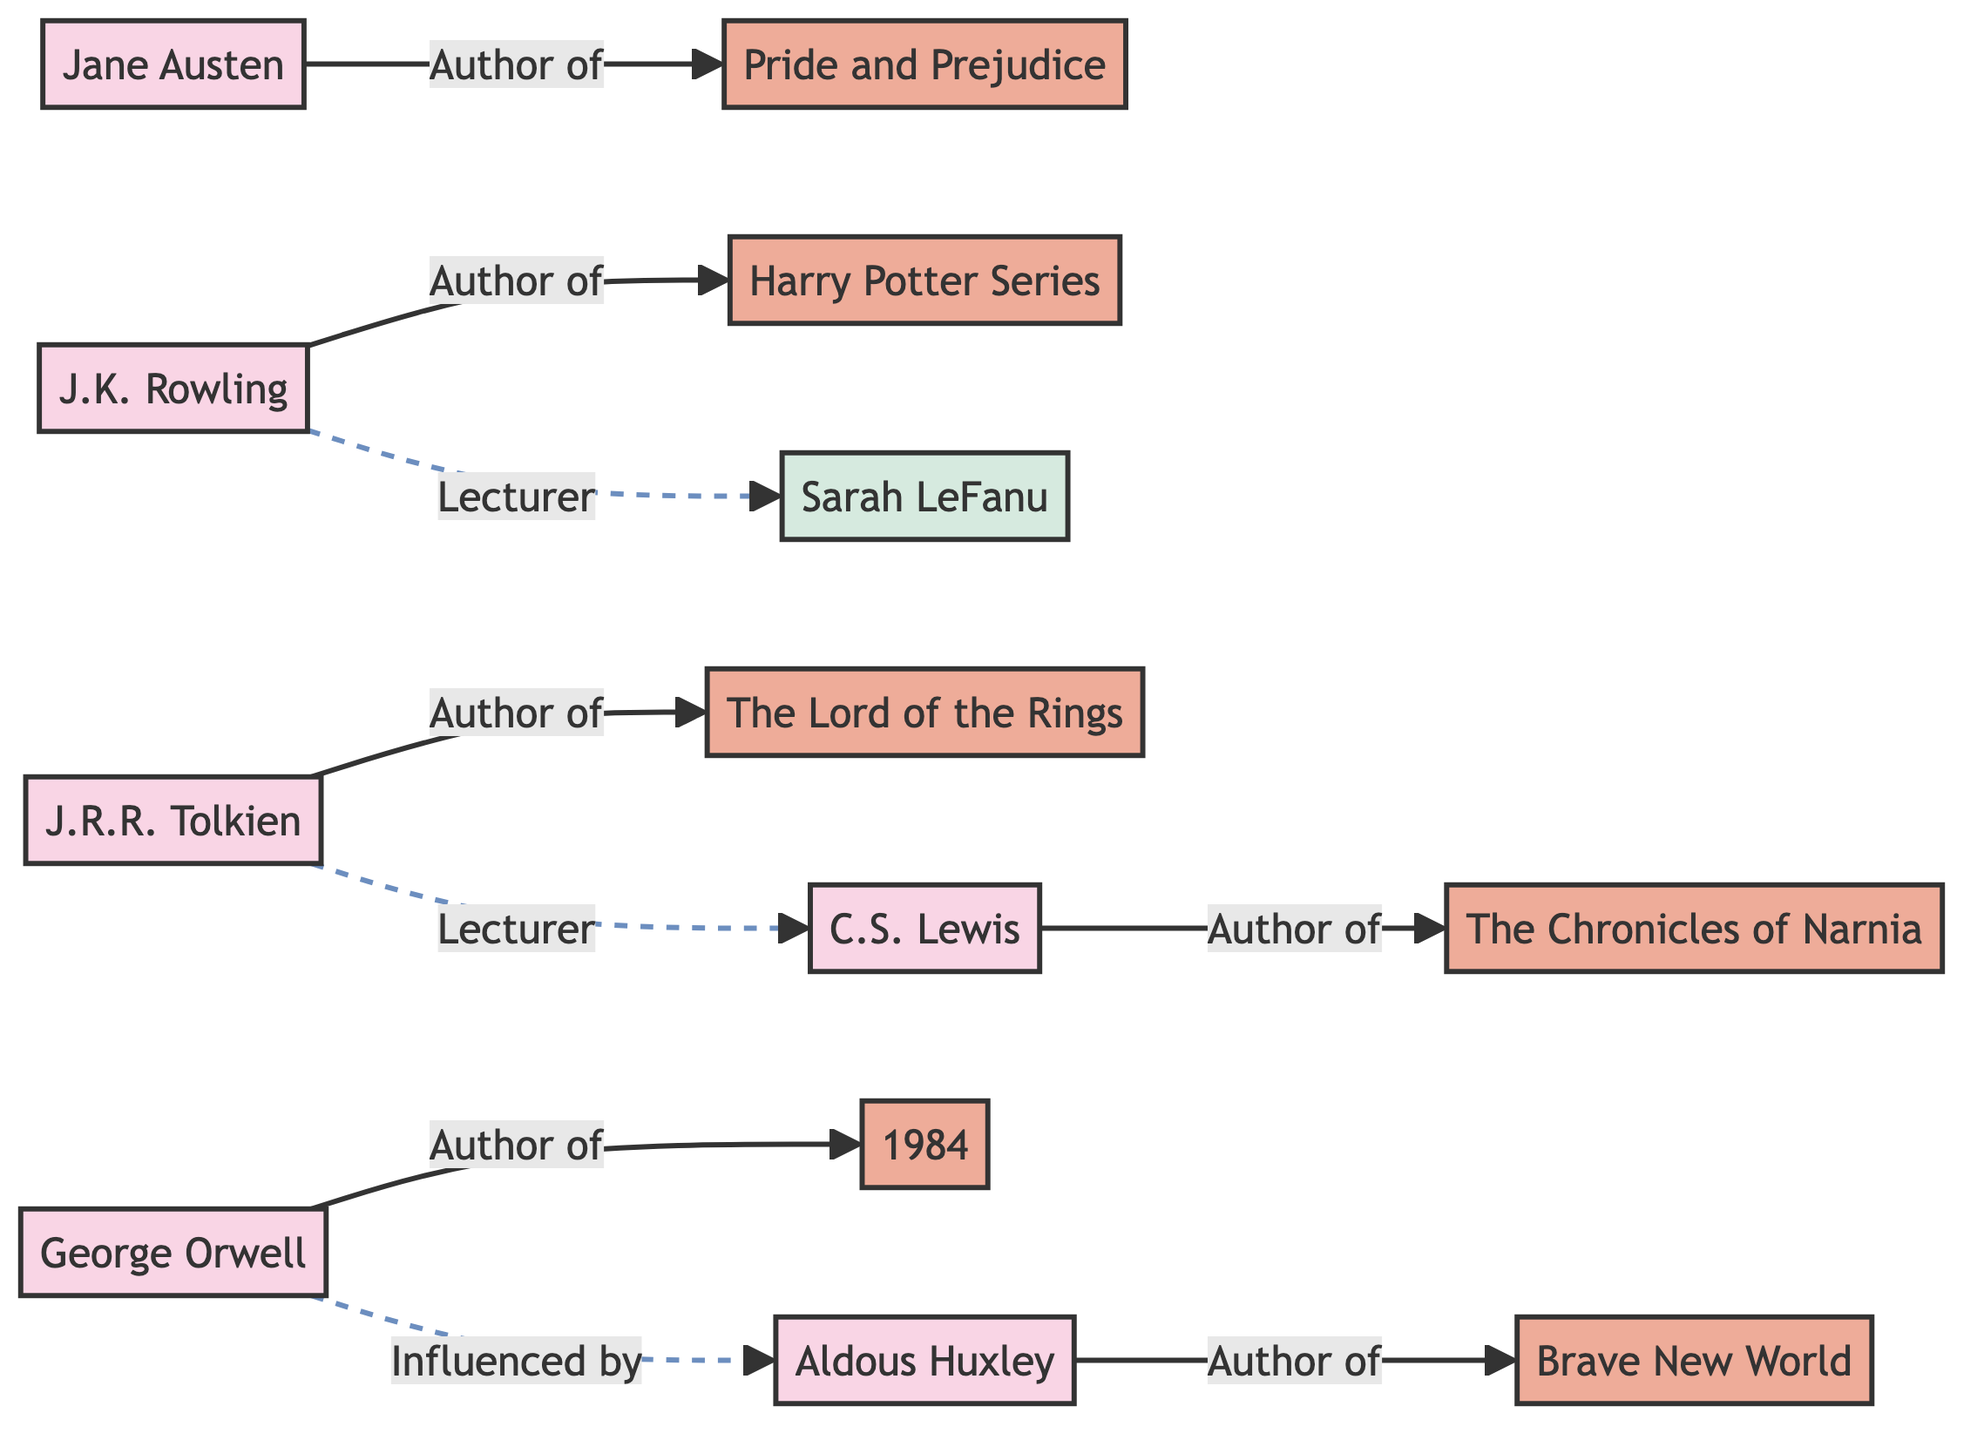What literary work is authored by J.K. Rowling? J.K. Rowling is directly connected to the node representing her literary work, which is the Harry Potter Series. The relationship is indicated by the arrow pointing from J.K. Rowling to the Harry Potter Series.
Answer: Harry Potter Series Who influenced George Orwell? The diagram shows a dashed line connecting George Orwell to Aldous Huxley, indicating that Orwell was influenced by Huxley. This relationship can be inferred from the distinct link type used in the diagram.
Answer: Aldous Huxley Which author is linked to The Chronicles of Narnia? The arrow indicates a direct connection from C.S. Lewis to The Chronicles of Narnia, making it clear that Lewis is the author of this work.
Answer: C.S. Lewis How many authors are represented in the diagram? By counting the nodes in the diagram labeled as authors, we identify J.K. Rowling, Jane Austen, J.R.R. Tolkien, C.S. Lewis, and George Orwell, resulting in a total of five authors.
Answer: 5 What relationship exists between J.R.R. Tolkien and C.S. Lewis? The diagram shows a dashed line from J.R.R. Tolkien to C.S. Lewis, indicating that Tolkien was a lecturer to Lewis. This can be identified by the dashed line style and its placement in relation to the authors' nodes.
Answer: Lecturer Which work is connected to Aldous Huxley? The diagram shows that Aldous Huxley authored Brave New World, illustrated by the direct link pointing from Huxley to Brave New World.
Answer: Brave New World How many works are connected to the authors in the diagram? Every author in the diagram is linked to one unique work, and counting the work nodes reveals six titles total: Harry Potter Series, Pride and Prejudice, The Lord of the Rings, The Chronicles of Narnia, 1984, and Brave New World.
Answer: 6 What is the primary color used to represent lecturers in the diagram? The lecturer nodes are shaded light blue, as indicated by the class definition which specifies the fill color for lecturer roles in the diagram.
Answer: Light blue Which author wrote Pride and Prejudice? The directed link between Jane Austen and Pride and Prejudice confirms that Austen is the author of this particular literary work.
Answer: Jane Austen 